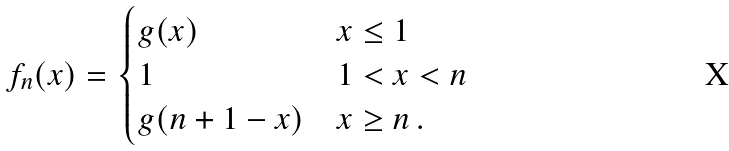Convert formula to latex. <formula><loc_0><loc_0><loc_500><loc_500>f _ { n } ( x ) = \begin{cases} g ( x ) & x \leq 1 \\ 1 & 1 < x < n \\ g ( n + 1 - x ) & x \geq n \, . \end{cases}</formula> 